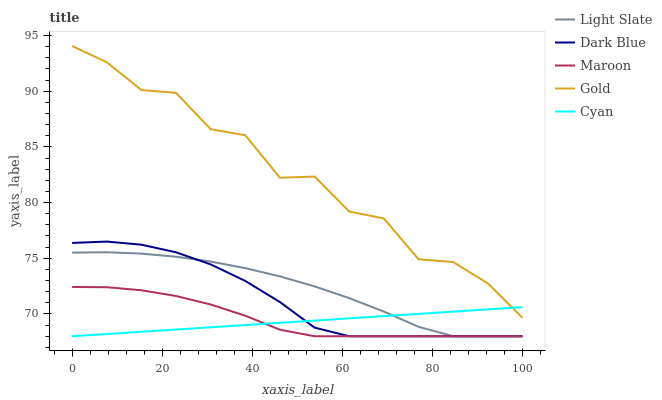Does Cyan have the minimum area under the curve?
Answer yes or no. Yes. Does Gold have the maximum area under the curve?
Answer yes or no. Yes. Does Dark Blue have the minimum area under the curve?
Answer yes or no. No. Does Dark Blue have the maximum area under the curve?
Answer yes or no. No. Is Cyan the smoothest?
Answer yes or no. Yes. Is Gold the roughest?
Answer yes or no. Yes. Is Dark Blue the smoothest?
Answer yes or no. No. Is Dark Blue the roughest?
Answer yes or no. No. Does Light Slate have the lowest value?
Answer yes or no. Yes. Does Gold have the lowest value?
Answer yes or no. No. Does Gold have the highest value?
Answer yes or no. Yes. Does Dark Blue have the highest value?
Answer yes or no. No. Is Light Slate less than Gold?
Answer yes or no. Yes. Is Gold greater than Dark Blue?
Answer yes or no. Yes. Does Light Slate intersect Maroon?
Answer yes or no. Yes. Is Light Slate less than Maroon?
Answer yes or no. No. Is Light Slate greater than Maroon?
Answer yes or no. No. Does Light Slate intersect Gold?
Answer yes or no. No. 